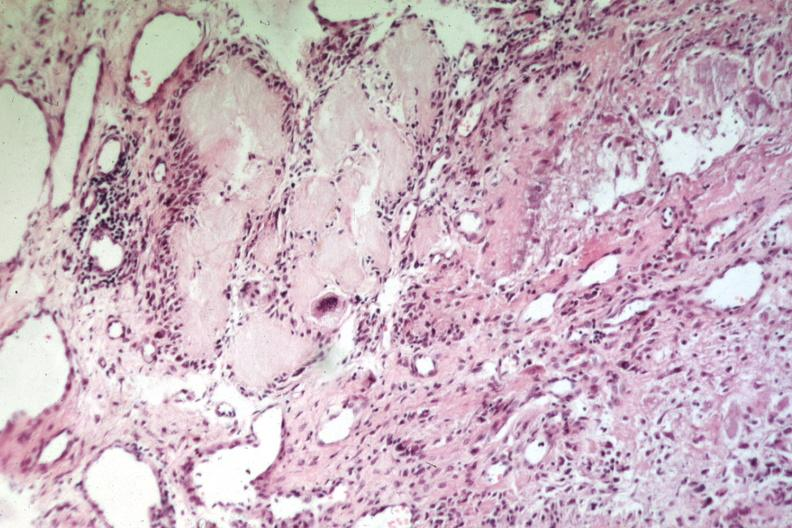does angiogram show uric acid deposits with giant cells easily recognizable as gout or uric acid tophus?
Answer the question using a single word or phrase. No 